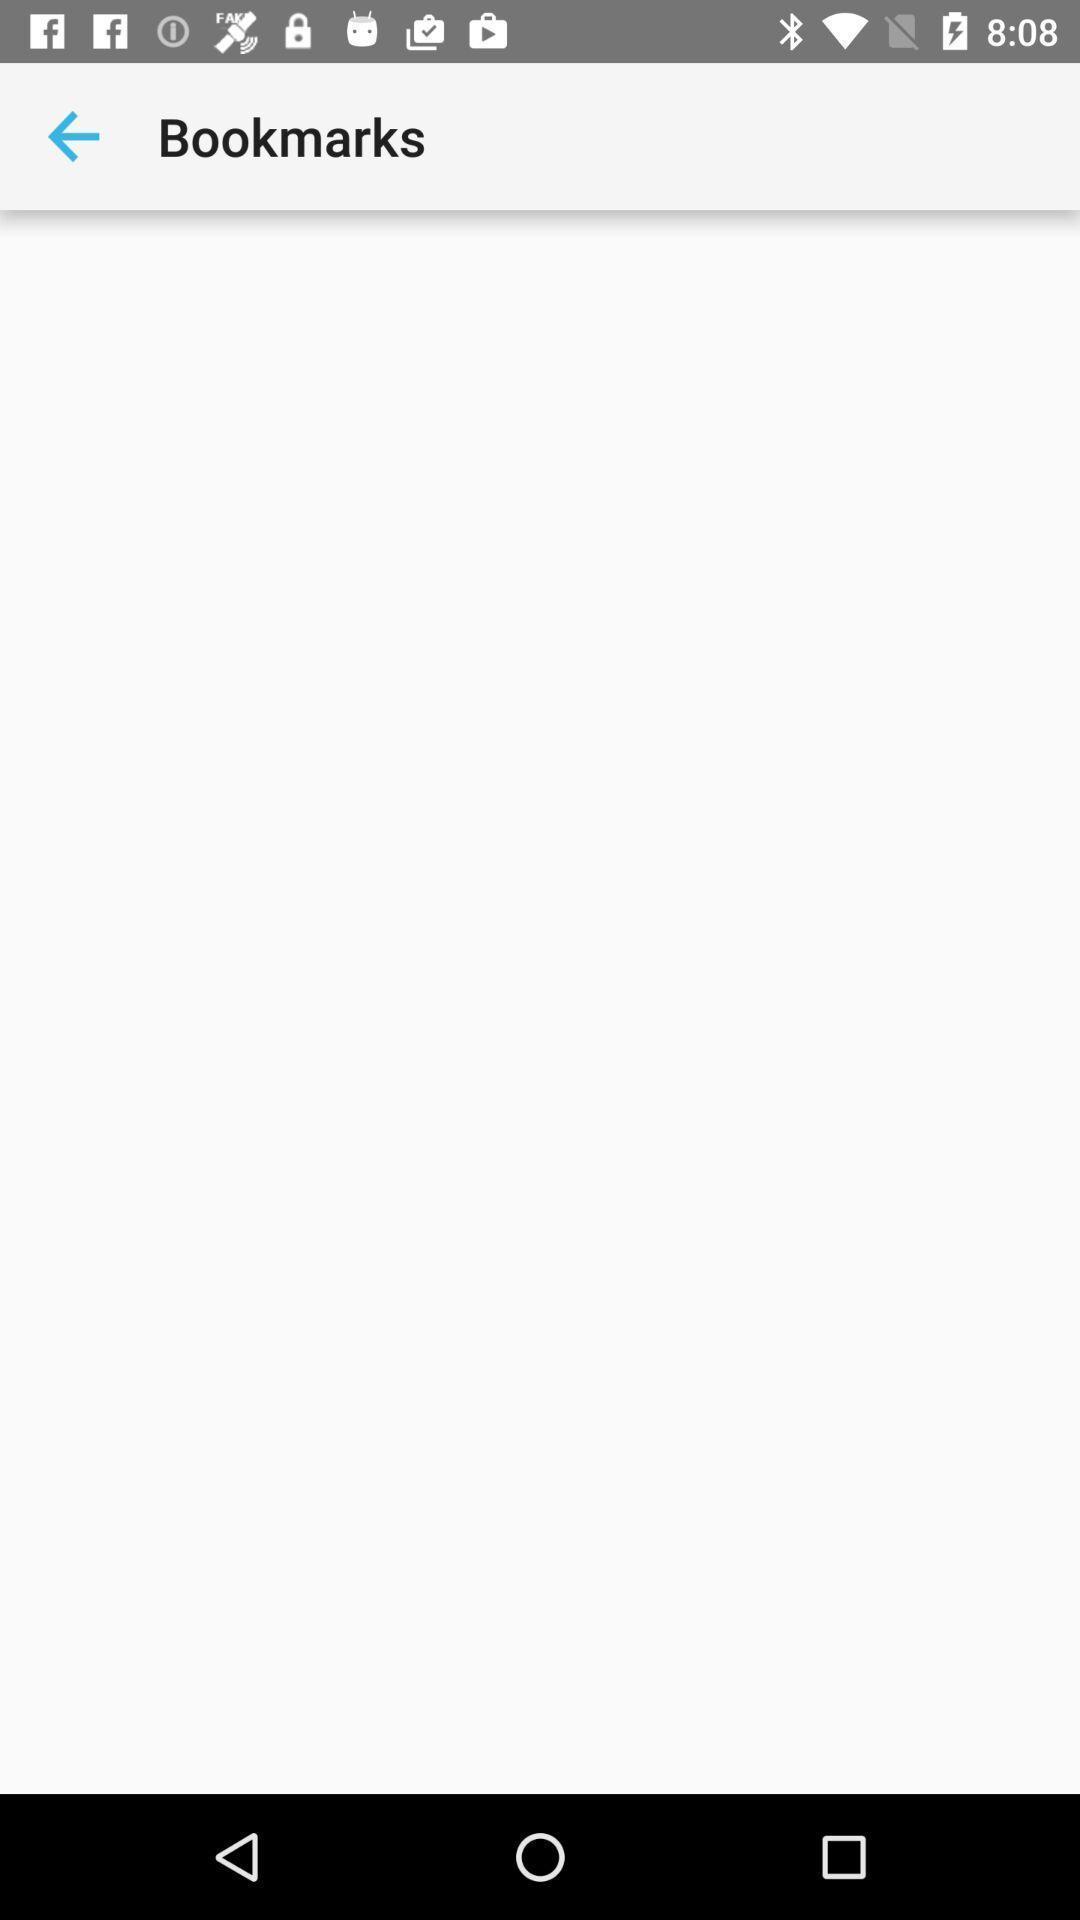Explain what's happening in this screen capture. Screen displaying bookmarks page of web application. 